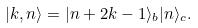Convert formula to latex. <formula><loc_0><loc_0><loc_500><loc_500>| k , n \rangle = | n + 2 k - 1 \rangle _ { b } | n \rangle _ { c } .</formula> 